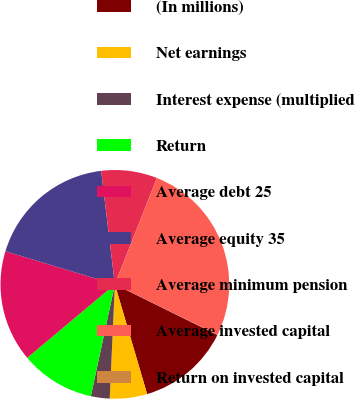Convert chart to OTSL. <chart><loc_0><loc_0><loc_500><loc_500><pie_chart><fcel>(In millions)<fcel>Net earnings<fcel>Interest expense (multiplied<fcel>Return<fcel>Average debt 25<fcel>Average equity 35<fcel>Average minimum pension<fcel>Average invested capital<fcel>Return on invested capital<nl><fcel>13.15%<fcel>5.27%<fcel>2.65%<fcel>10.53%<fcel>15.78%<fcel>18.41%<fcel>7.9%<fcel>26.29%<fcel>0.02%<nl></chart> 